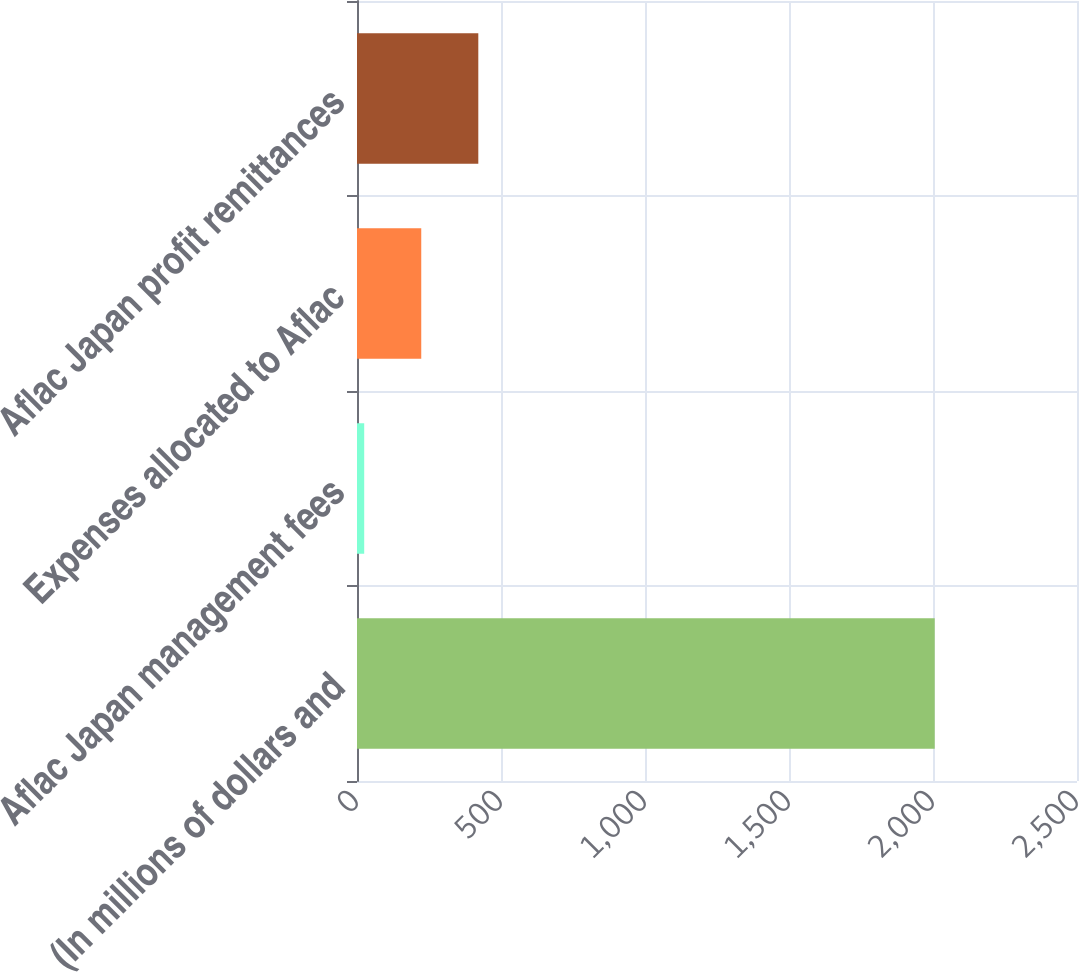Convert chart. <chart><loc_0><loc_0><loc_500><loc_500><bar_chart><fcel>(In millions of dollars and<fcel>Aflac Japan management fees<fcel>Expenses allocated to Aflac<fcel>Aflac Japan profit remittances<nl><fcel>2006<fcel>25<fcel>223.1<fcel>421.2<nl></chart> 